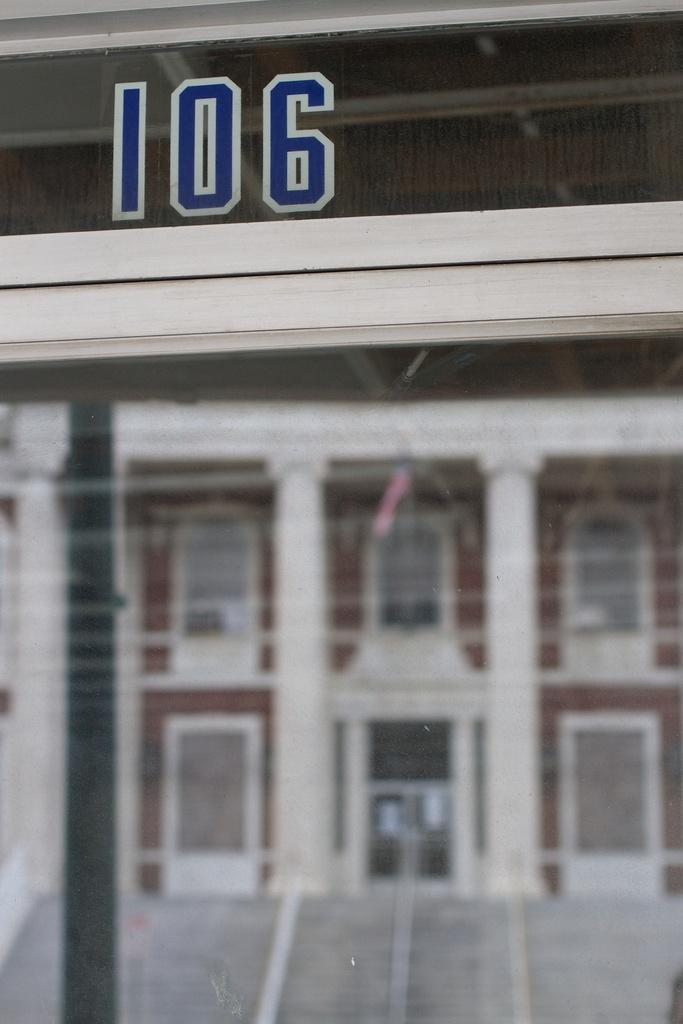Provide a one-sentence caption for the provided image. a building with the number 106 at the top. 